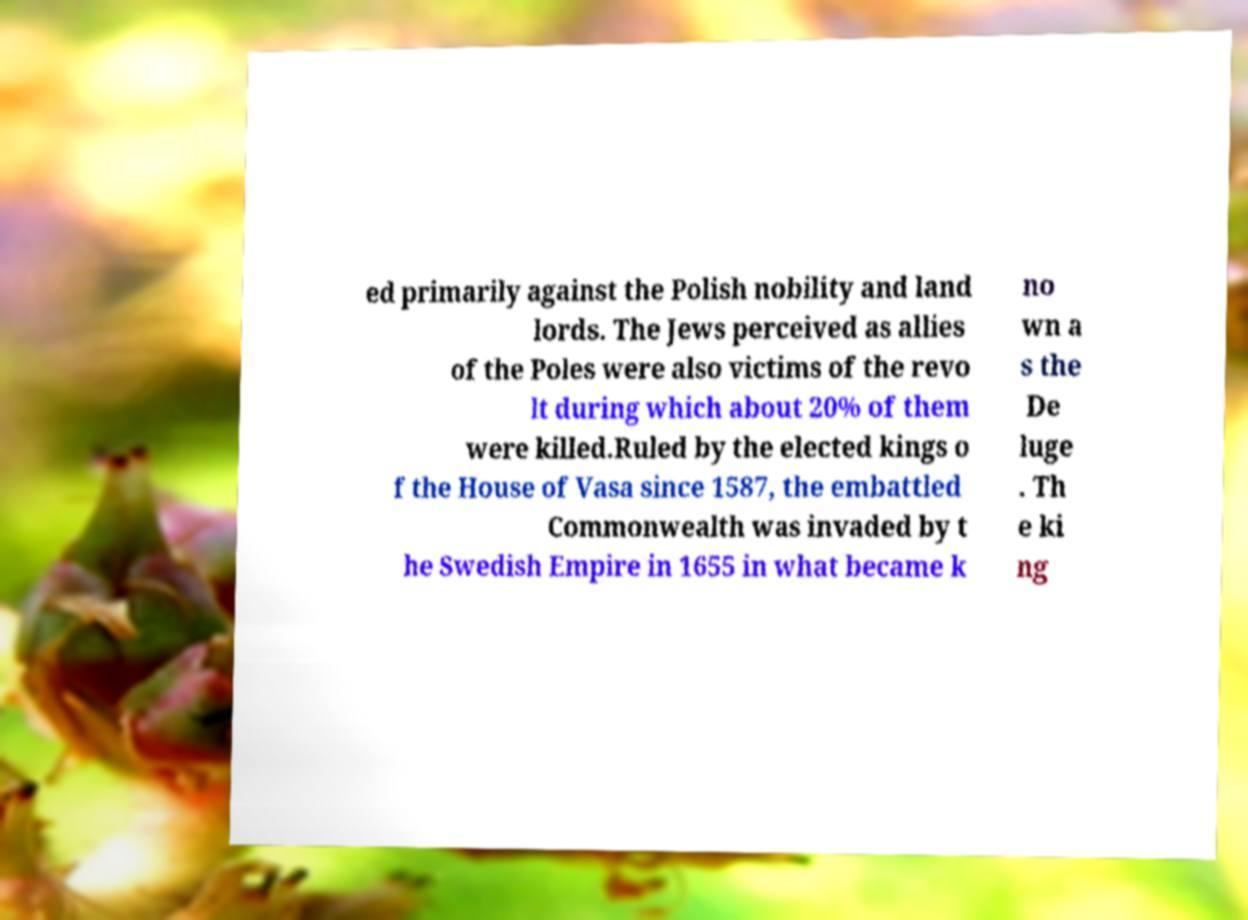Can you accurately transcribe the text from the provided image for me? ed primarily against the Polish nobility and land lords. The Jews perceived as allies of the Poles were also victims of the revo lt during which about 20% of them were killed.Ruled by the elected kings o f the House of Vasa since 1587, the embattled Commonwealth was invaded by t he Swedish Empire in 1655 in what became k no wn a s the De luge . Th e ki ng 